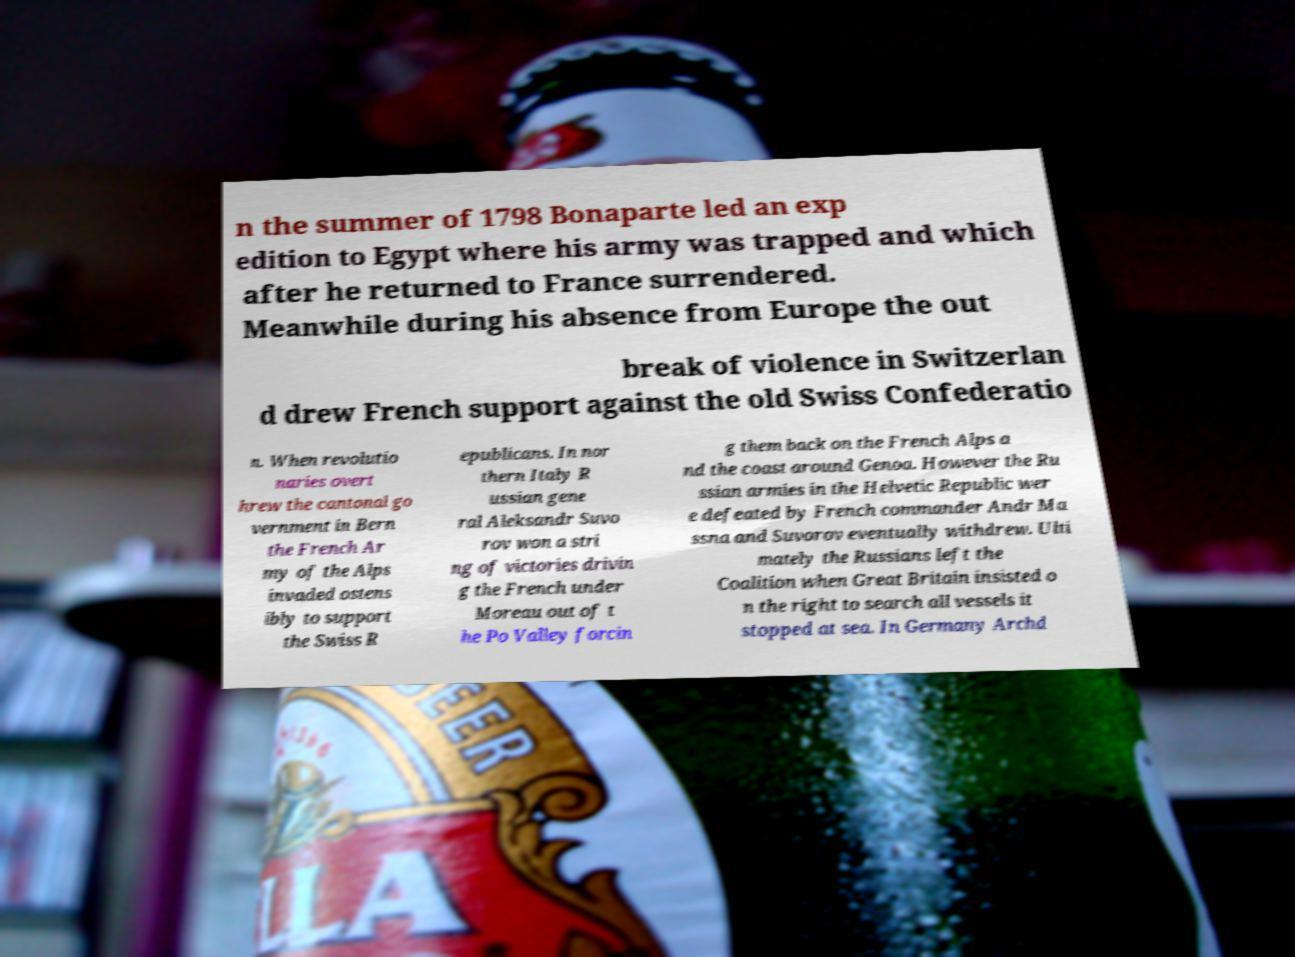What messages or text are displayed in this image? I need them in a readable, typed format. n the summer of 1798 Bonaparte led an exp edition to Egypt where his army was trapped and which after he returned to France surrendered. Meanwhile during his absence from Europe the out break of violence in Switzerlan d drew French support against the old Swiss Confederatio n. When revolutio naries overt hrew the cantonal go vernment in Bern the French Ar my of the Alps invaded ostens ibly to support the Swiss R epublicans. In nor thern Italy R ussian gene ral Aleksandr Suvo rov won a stri ng of victories drivin g the French under Moreau out of t he Po Valley forcin g them back on the French Alps a nd the coast around Genoa. However the Ru ssian armies in the Helvetic Republic wer e defeated by French commander Andr Ma ssna and Suvorov eventually withdrew. Ulti mately the Russians left the Coalition when Great Britain insisted o n the right to search all vessels it stopped at sea. In Germany Archd 